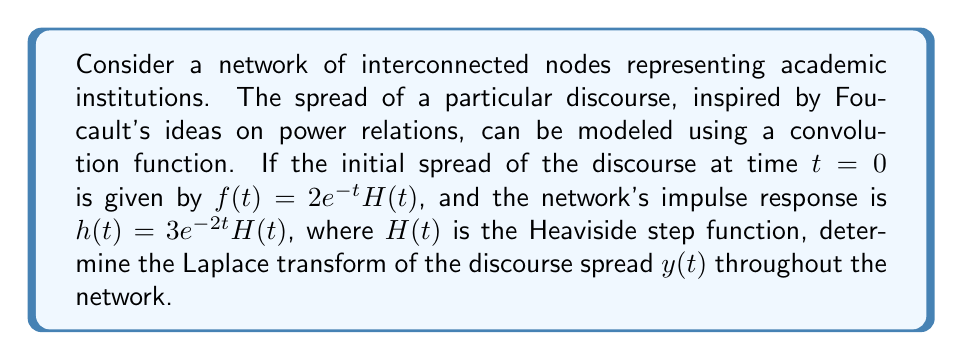Help me with this question. To solve this problem, we'll follow these steps:

1) Recall that the spread of discourse in the network can be modeled as the convolution of the initial spread $f(t)$ and the network's impulse response $h(t)$:

   $y(t) = f(t) * h(t)$

2) The Laplace transform of a convolution is the product of the Laplace transforms of the individual functions:

   $\mathcal{L}\{y(t)\} = \mathcal{L}\{f(t)\} \cdot \mathcal{L}\{h(t)\}$

3) Let's find $\mathcal{L}\{f(t)\}$:
   
   $f(t) = 2e^{-t}H(t)$
   
   $\mathcal{L}\{f(t)\} = \mathcal{L}\{2e^{-t}H(t)\} = \frac{2}{s+1}$

4) Now, let's find $\mathcal{L}\{h(t)\}$:
   
   $h(t) = 3e^{-2t}H(t)$
   
   $\mathcal{L}\{h(t)\} = \mathcal{L}\{3e^{-2t}H(t)\} = \frac{3}{s+2}$

5) Now we can multiply these results:

   $\mathcal{L}\{y(t)\} = \frac{2}{s+1} \cdot \frac{3}{s+2} = \frac{6}{(s+1)(s+2)}$

6) To simplify this further, we can use partial fraction decomposition:

   $\frac{6}{(s+1)(s+2)} = \frac{A}{s+1} + \frac{B}{s+2}$

   $6 = A(s+2) + B(s+1)$

   When $s = -1$: $6 = A(1) + B(0)$, so $A = 6$
   When $s = -2$: $6 = A(0) + B(-1)$, so $B = -6$

7) Therefore, the final result is:

   $\mathcal{L}\{y(t)\} = \frac{6}{s+1} - \frac{6}{s+2}$

This Laplace transform represents the spread of the Foucauldian discourse throughout the network of academic institutions over time.
Answer: $$\mathcal{L}\{y(t)\} = \frac{6}{s+1} - \frac{6}{s+2}$$ 